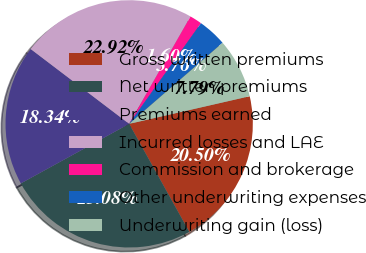Convert chart. <chart><loc_0><loc_0><loc_500><loc_500><pie_chart><fcel>Gross written premiums<fcel>Net written premiums<fcel>Premiums earned<fcel>Incurred losses and LAE<fcel>Commission and brokerage<fcel>Other underwriting expenses<fcel>Underwriting gain (loss)<nl><fcel>20.5%<fcel>25.08%<fcel>18.34%<fcel>22.92%<fcel>1.6%<fcel>3.76%<fcel>7.79%<nl></chart> 